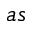<formula> <loc_0><loc_0><loc_500><loc_500>a s</formula> 